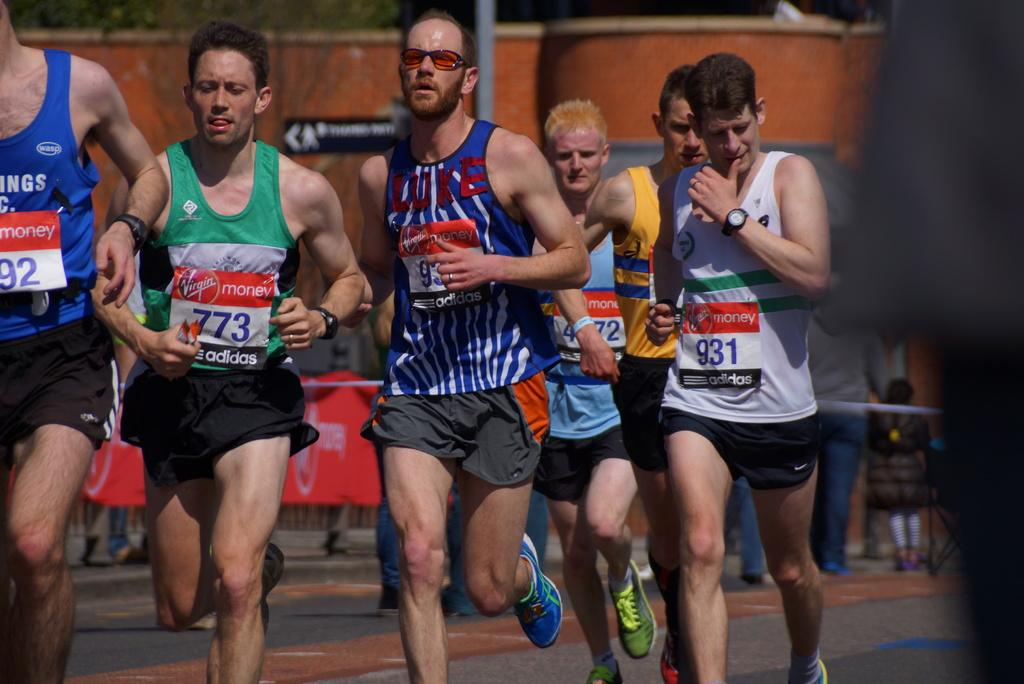What are the people in the image doing? The people in the image are running. Can you describe the background of the image? There are people in the background of the image. What can be seen on the ground in the image? The ground is visible in the image, and there are objects on it. What is the purpose of the pole in the image? The pole's purpose is not specified in the image, but it could be used for various reasons such as support or signage. What type of containers can be seen in the image? There are containers in the image, but their contents are not specified. What is the signboard in the image used for? The signboard in the image is used for displaying information or advertising. Can you hear the rhythm of the bone in the image? There is no bone present in the image, so it is not possible to hear its rhythm. 